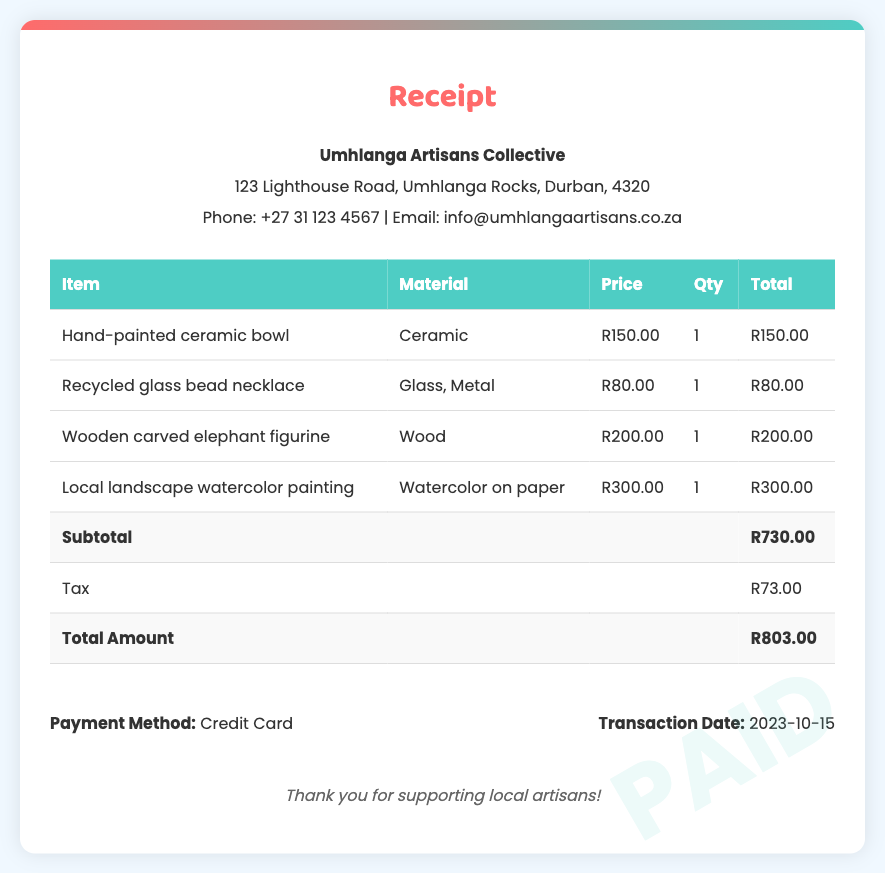What is the total amount? The total amount is indicated at the bottom of the receipt, showing the sum of subtotal and tax.
Answer: R803.00 Who is the vendor? The vendor's name and contact information are provided at the top of the receipt.
Answer: Umhlanga Artisans Collective What date was the transaction made? The transaction date is specified in the payment info section of the document.
Answer: 2023-10-15 How many items were purchased? The number of items is represented in the table of items purchased.
Answer: 4 What is the price of the hand-painted ceramic bowl? The price is listed in the item's row within the table.
Answer: R150.00 What is the tax amount? The tax amount is mentioned in the subtotal section of the document.
Answer: R73.00 What material is the recycled glass bead necklace made of? The material is found in the corresponding row of the item table.
Answer: Glass, Metal What payment method was used? The payment method is specified in the payment info section.
Answer: Credit Card What type of document is this? This document is a formal receipt for purchases made.
Answer: Receipt 